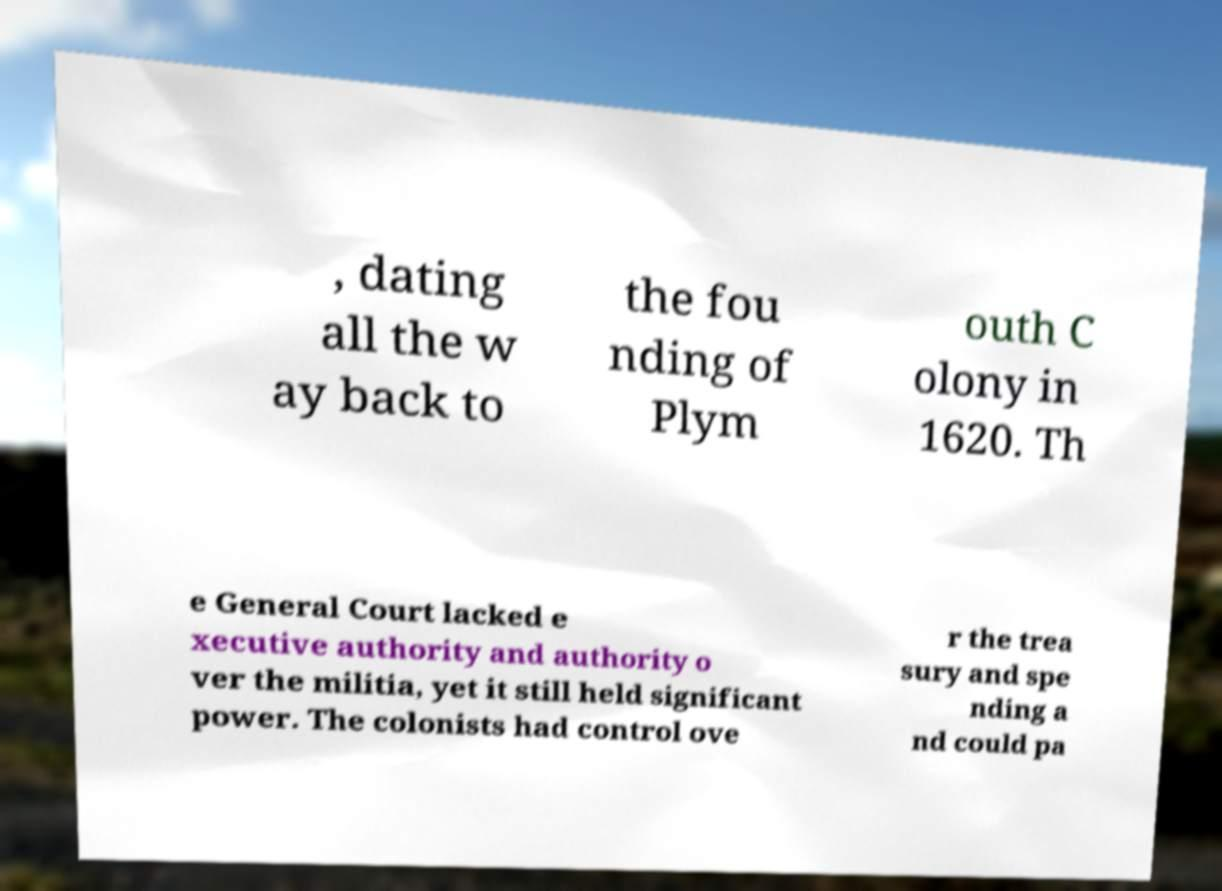What messages or text are displayed in this image? I need them in a readable, typed format. , dating all the w ay back to the fou nding of Plym outh C olony in 1620. Th e General Court lacked e xecutive authority and authority o ver the militia, yet it still held significant power. The colonists had control ove r the trea sury and spe nding a nd could pa 